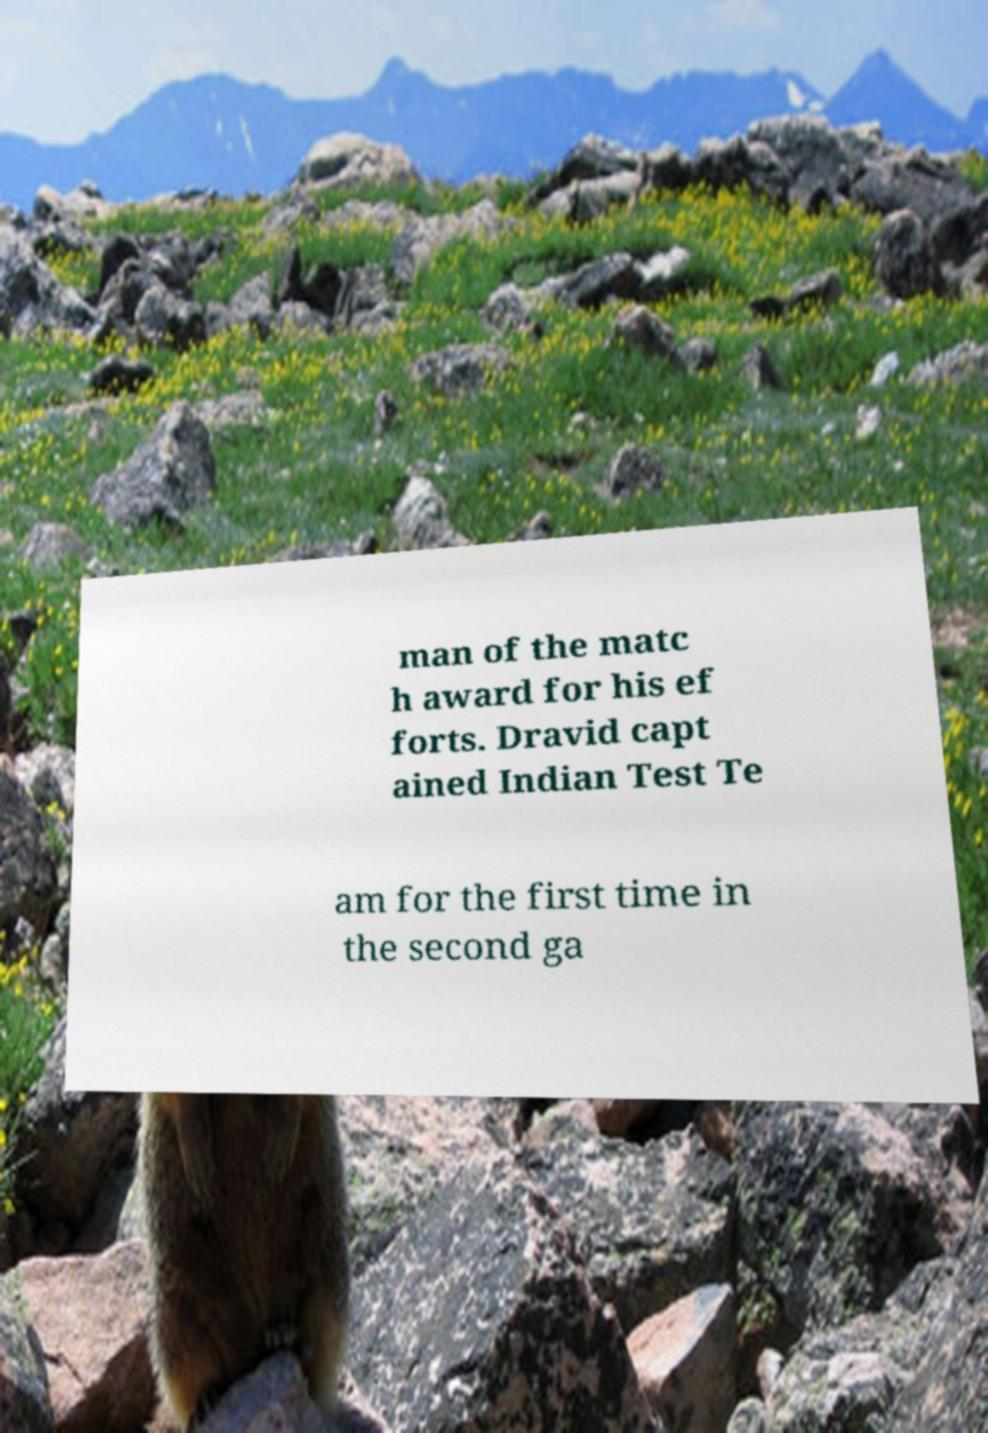Can you accurately transcribe the text from the provided image for me? man of the matc h award for his ef forts. Dravid capt ained Indian Test Te am for the first time in the second ga 